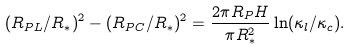<formula> <loc_0><loc_0><loc_500><loc_500>( R _ { P L } / R _ { * } ) ^ { 2 } - ( R _ { P C } / R _ { * } ) ^ { 2 } = \frac { 2 \pi R _ { P } H } { \pi R _ { * } ^ { 2 } } \ln ( \kappa _ { l } / \kappa _ { c } ) .</formula> 